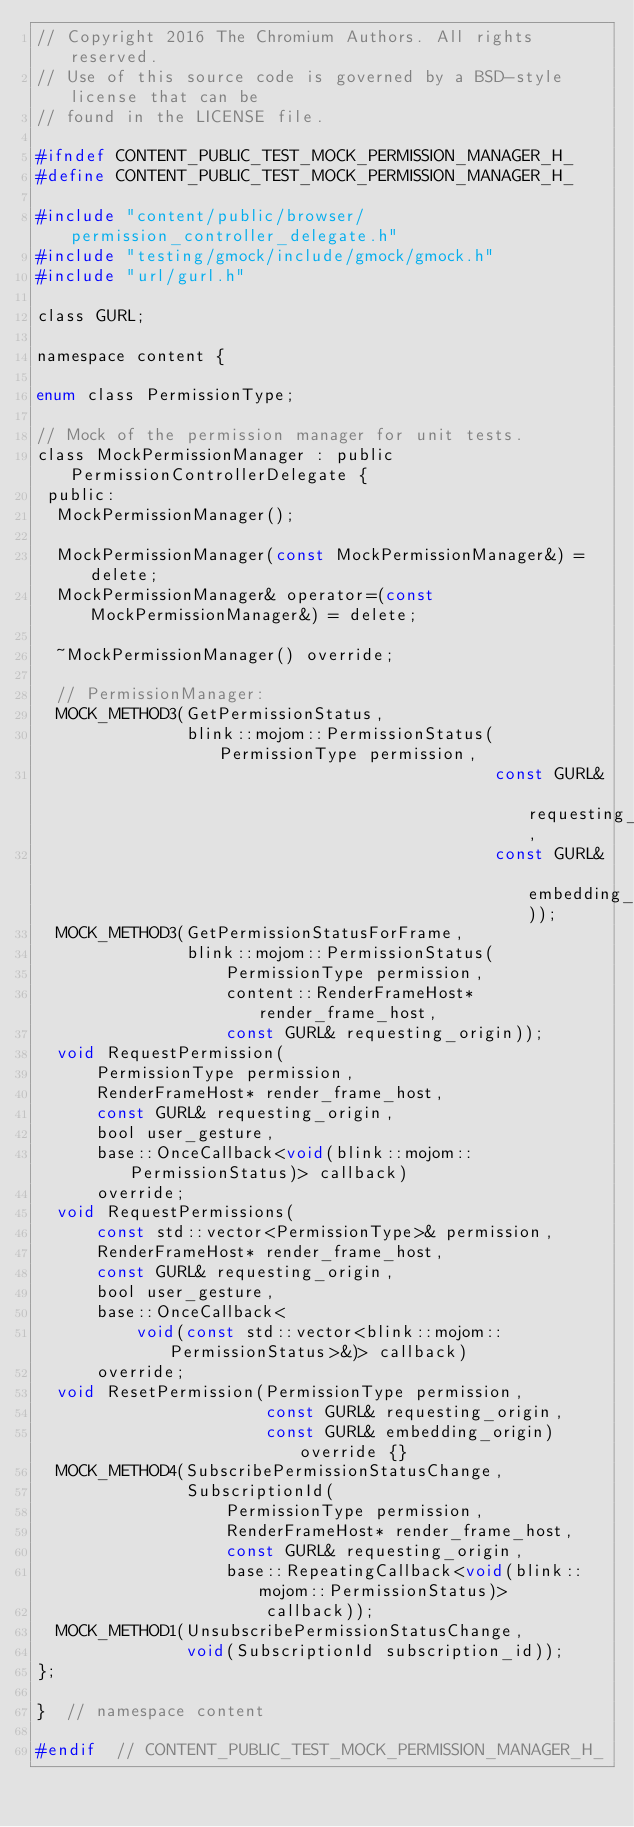Convert code to text. <code><loc_0><loc_0><loc_500><loc_500><_C_>// Copyright 2016 The Chromium Authors. All rights reserved.
// Use of this source code is governed by a BSD-style license that can be
// found in the LICENSE file.

#ifndef CONTENT_PUBLIC_TEST_MOCK_PERMISSION_MANAGER_H_
#define CONTENT_PUBLIC_TEST_MOCK_PERMISSION_MANAGER_H_

#include "content/public/browser/permission_controller_delegate.h"
#include "testing/gmock/include/gmock/gmock.h"
#include "url/gurl.h"

class GURL;

namespace content {

enum class PermissionType;

// Mock of the permission manager for unit tests.
class MockPermissionManager : public PermissionControllerDelegate {
 public:
  MockPermissionManager();

  MockPermissionManager(const MockPermissionManager&) = delete;
  MockPermissionManager& operator=(const MockPermissionManager&) = delete;

  ~MockPermissionManager() override;

  // PermissionManager:
  MOCK_METHOD3(GetPermissionStatus,
               blink::mojom::PermissionStatus(PermissionType permission,
                                              const GURL& requesting_origin,
                                              const GURL& embedding_origin));
  MOCK_METHOD3(GetPermissionStatusForFrame,
               blink::mojom::PermissionStatus(
                   PermissionType permission,
                   content::RenderFrameHost* render_frame_host,
                   const GURL& requesting_origin));
  void RequestPermission(
      PermissionType permission,
      RenderFrameHost* render_frame_host,
      const GURL& requesting_origin,
      bool user_gesture,
      base::OnceCallback<void(blink::mojom::PermissionStatus)> callback)
      override;
  void RequestPermissions(
      const std::vector<PermissionType>& permission,
      RenderFrameHost* render_frame_host,
      const GURL& requesting_origin,
      bool user_gesture,
      base::OnceCallback<
          void(const std::vector<blink::mojom::PermissionStatus>&)> callback)
      override;
  void ResetPermission(PermissionType permission,
                       const GURL& requesting_origin,
                       const GURL& embedding_origin) override {}
  MOCK_METHOD4(SubscribePermissionStatusChange,
               SubscriptionId(
                   PermissionType permission,
                   RenderFrameHost* render_frame_host,
                   const GURL& requesting_origin,
                   base::RepeatingCallback<void(blink::mojom::PermissionStatus)>
                       callback));
  MOCK_METHOD1(UnsubscribePermissionStatusChange,
               void(SubscriptionId subscription_id));
};

}  // namespace content

#endif  // CONTENT_PUBLIC_TEST_MOCK_PERMISSION_MANAGER_H_
</code> 